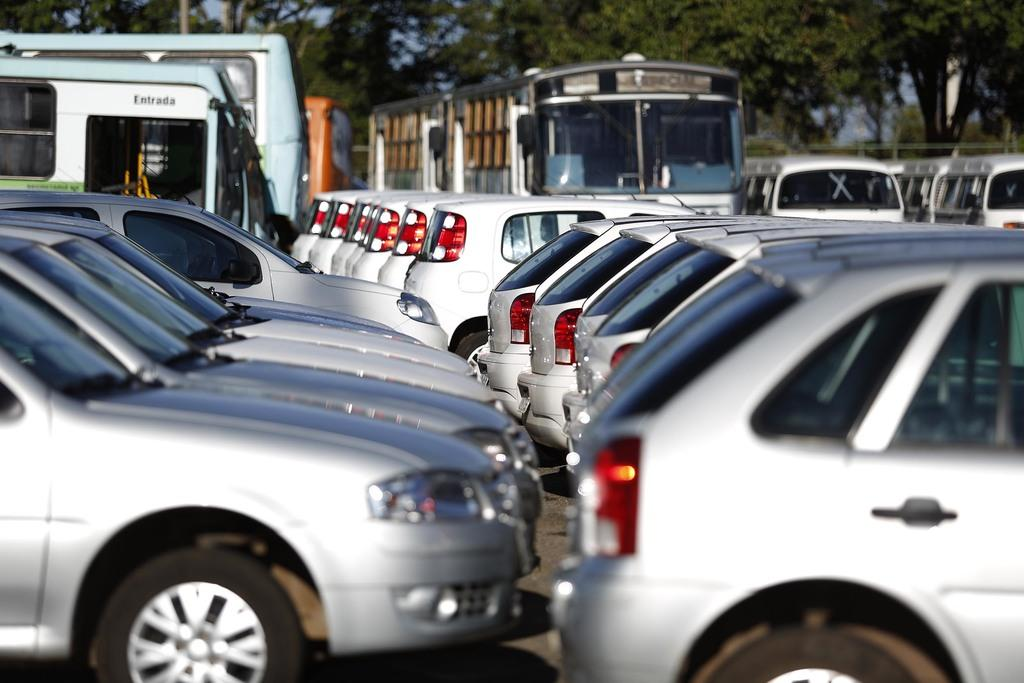What can be seen on the road in the image? There are vehicles on the road in the image. What type of natural elements can be seen in the background of the image? There are trees visible in the background of the image. Where is the scarecrow located in the image? There is no scarecrow present in the image. What type of treatment is being administered to the vehicles in the image? There is no treatment being administered to the vehicles in the image; they are simply driving on the road. 